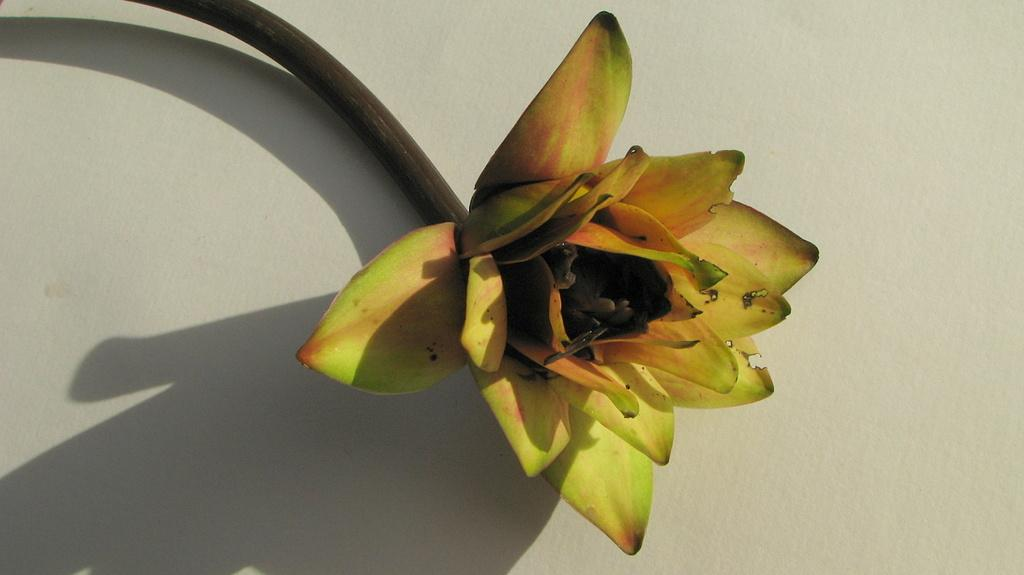What is the main subject of the image? There is a flower in the image. What is the color of the background in the image? The background of the image is white. How many bubbles are floating around the flower in the image? There are no bubbles present in the image. What is the chance of a robin appearing in the image? There is no mention of a robin in the image, so it cannot be determined if there is a chance of one appearing. 